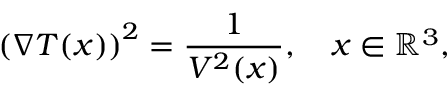Convert formula to latex. <formula><loc_0><loc_0><loc_500><loc_500>\left ( \nabla T ( x ) \right ) ^ { 2 } = \frac { 1 } { V ^ { 2 } ( x ) } , \quad x \in \mathbb { R } ^ { 3 } ,</formula> 